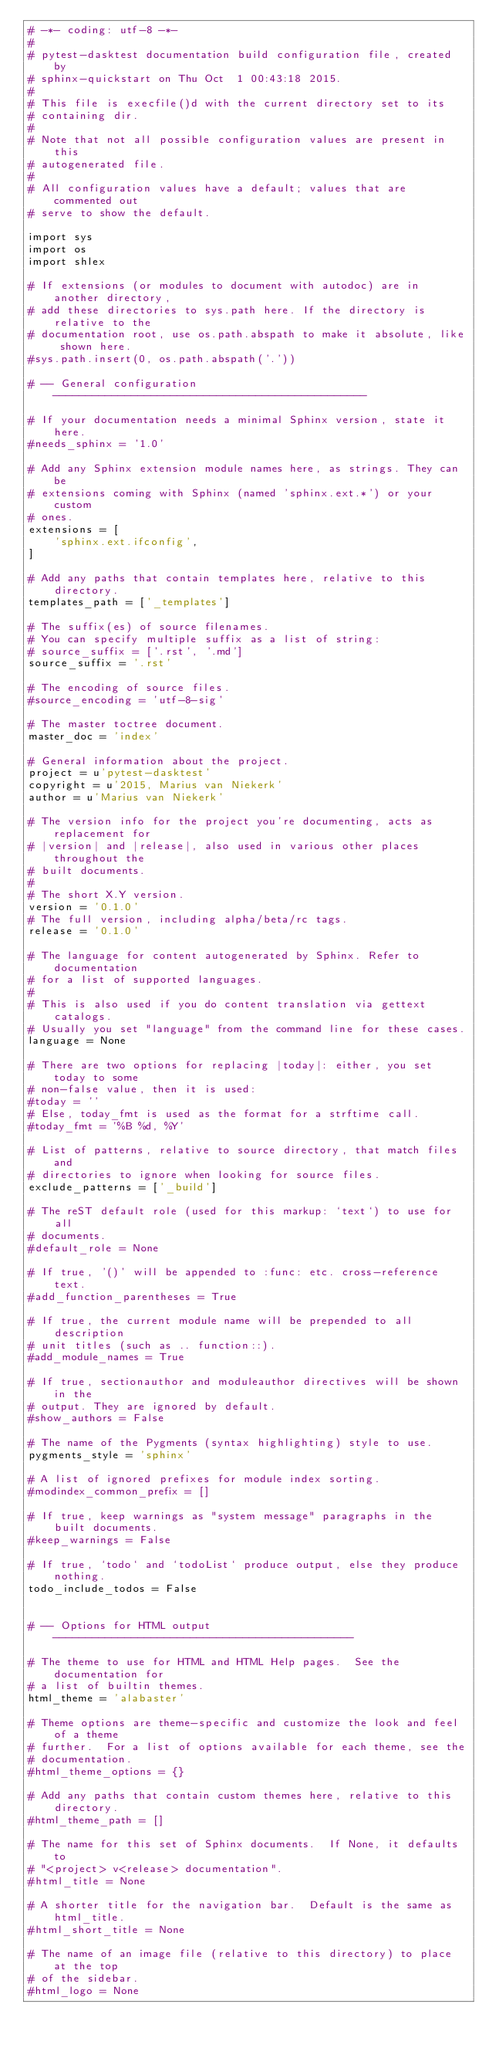Convert code to text. <code><loc_0><loc_0><loc_500><loc_500><_Python_># -*- coding: utf-8 -*-
#
# pytest-dasktest documentation build configuration file, created by
# sphinx-quickstart on Thu Oct  1 00:43:18 2015.
#
# This file is execfile()d with the current directory set to its
# containing dir.
#
# Note that not all possible configuration values are present in this
# autogenerated file.
#
# All configuration values have a default; values that are commented out
# serve to show the default.

import sys
import os
import shlex

# If extensions (or modules to document with autodoc) are in another directory,
# add these directories to sys.path here. If the directory is relative to the
# documentation root, use os.path.abspath to make it absolute, like shown here.
#sys.path.insert(0, os.path.abspath('.'))

# -- General configuration ------------------------------------------------

# If your documentation needs a minimal Sphinx version, state it here.
#needs_sphinx = '1.0'

# Add any Sphinx extension module names here, as strings. They can be
# extensions coming with Sphinx (named 'sphinx.ext.*') or your custom
# ones.
extensions = [
    'sphinx.ext.ifconfig',
]

# Add any paths that contain templates here, relative to this directory.
templates_path = ['_templates']

# The suffix(es) of source filenames.
# You can specify multiple suffix as a list of string:
# source_suffix = ['.rst', '.md']
source_suffix = '.rst'

# The encoding of source files.
#source_encoding = 'utf-8-sig'

# The master toctree document.
master_doc = 'index'

# General information about the project.
project = u'pytest-dasktest'
copyright = u'2015, Marius van Niekerk'
author = u'Marius van Niekerk'

# The version info for the project you're documenting, acts as replacement for
# |version| and |release|, also used in various other places throughout the
# built documents.
#
# The short X.Y version.
version = '0.1.0'
# The full version, including alpha/beta/rc tags.
release = '0.1.0'

# The language for content autogenerated by Sphinx. Refer to documentation
# for a list of supported languages.
#
# This is also used if you do content translation via gettext catalogs.
# Usually you set "language" from the command line for these cases.
language = None

# There are two options for replacing |today|: either, you set today to some
# non-false value, then it is used:
#today = ''
# Else, today_fmt is used as the format for a strftime call.
#today_fmt = '%B %d, %Y'

# List of patterns, relative to source directory, that match files and
# directories to ignore when looking for source files.
exclude_patterns = ['_build']

# The reST default role (used for this markup: `text`) to use for all
# documents.
#default_role = None

# If true, '()' will be appended to :func: etc. cross-reference text.
#add_function_parentheses = True

# If true, the current module name will be prepended to all description
# unit titles (such as .. function::).
#add_module_names = True

# If true, sectionauthor and moduleauthor directives will be shown in the
# output. They are ignored by default.
#show_authors = False

# The name of the Pygments (syntax highlighting) style to use.
pygments_style = 'sphinx'

# A list of ignored prefixes for module index sorting.
#modindex_common_prefix = []

# If true, keep warnings as "system message" paragraphs in the built documents.
#keep_warnings = False

# If true, `todo` and `todoList` produce output, else they produce nothing.
todo_include_todos = False


# -- Options for HTML output ----------------------------------------------

# The theme to use for HTML and HTML Help pages.  See the documentation for
# a list of builtin themes.
html_theme = 'alabaster'

# Theme options are theme-specific and customize the look and feel of a theme
# further.  For a list of options available for each theme, see the
# documentation.
#html_theme_options = {}

# Add any paths that contain custom themes here, relative to this directory.
#html_theme_path = []

# The name for this set of Sphinx documents.  If None, it defaults to
# "<project> v<release> documentation".
#html_title = None

# A shorter title for the navigation bar.  Default is the same as html_title.
#html_short_title = None

# The name of an image file (relative to this directory) to place at the top
# of the sidebar.
#html_logo = None
</code> 